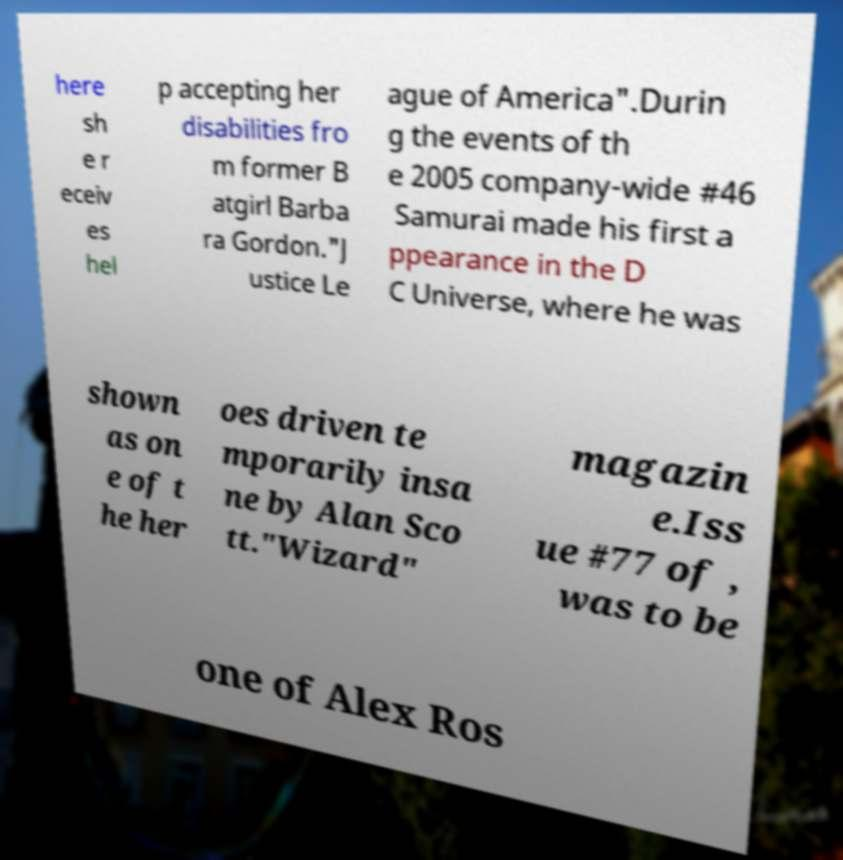I need the written content from this picture converted into text. Can you do that? here sh e r eceiv es hel p accepting her disabilities fro m former B atgirl Barba ra Gordon."J ustice Le ague of America".Durin g the events of th e 2005 company-wide #46 Samurai made his first a ppearance in the D C Universe, where he was shown as on e of t he her oes driven te mporarily insa ne by Alan Sco tt."Wizard" magazin e.Iss ue #77 of , was to be one of Alex Ros 